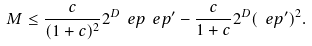<formula> <loc_0><loc_0><loc_500><loc_500>M \leq \frac { c } { ( 1 + c ) ^ { 2 } } 2 ^ { D } \ e p \ e p ^ { \prime } - \frac { c } { 1 + c } 2 ^ { D } ( \ e p ^ { \prime } ) ^ { 2 } .</formula> 